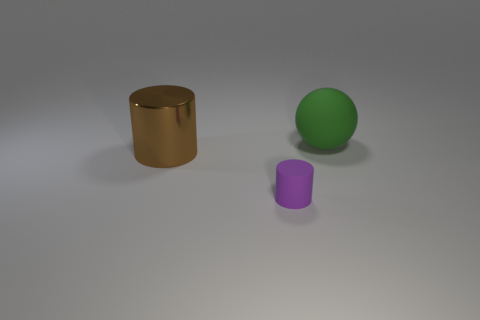Subtract 1 cylinders. How many cylinders are left? 1 Add 1 green metal balls. How many objects exist? 4 Subtract all brown cylinders. How many cylinders are left? 1 Subtract all balls. How many objects are left? 2 Add 1 large brown shiny cylinders. How many large brown shiny cylinders are left? 2 Add 1 large balls. How many large balls exist? 2 Subtract 0 gray cylinders. How many objects are left? 3 Subtract all brown cylinders. Subtract all yellow balls. How many cylinders are left? 1 Subtract all yellow blocks. How many brown cylinders are left? 1 Subtract all big green spheres. Subtract all brown metallic cylinders. How many objects are left? 1 